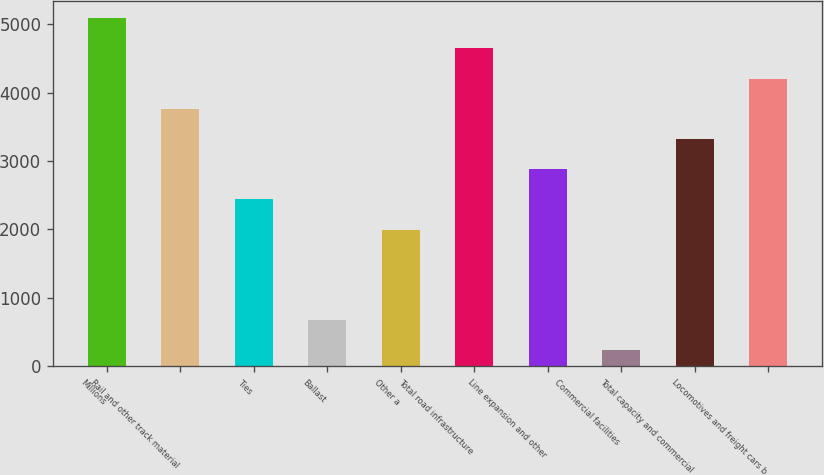Convert chart. <chart><loc_0><loc_0><loc_500><loc_500><bar_chart><fcel>Millions<fcel>Rail and other track material<fcel>Ties<fcel>Ballast<fcel>Other a<fcel>Total road infrastructure<fcel>Line expansion and other<fcel>Commercial facilities<fcel>Total capacity and commercial<fcel>Locomotives and freight cars b<nl><fcel>5092.3<fcel>3765.4<fcel>2438.5<fcel>669.3<fcel>1996.2<fcel>4650<fcel>2880.8<fcel>227<fcel>3323.1<fcel>4207.7<nl></chart> 